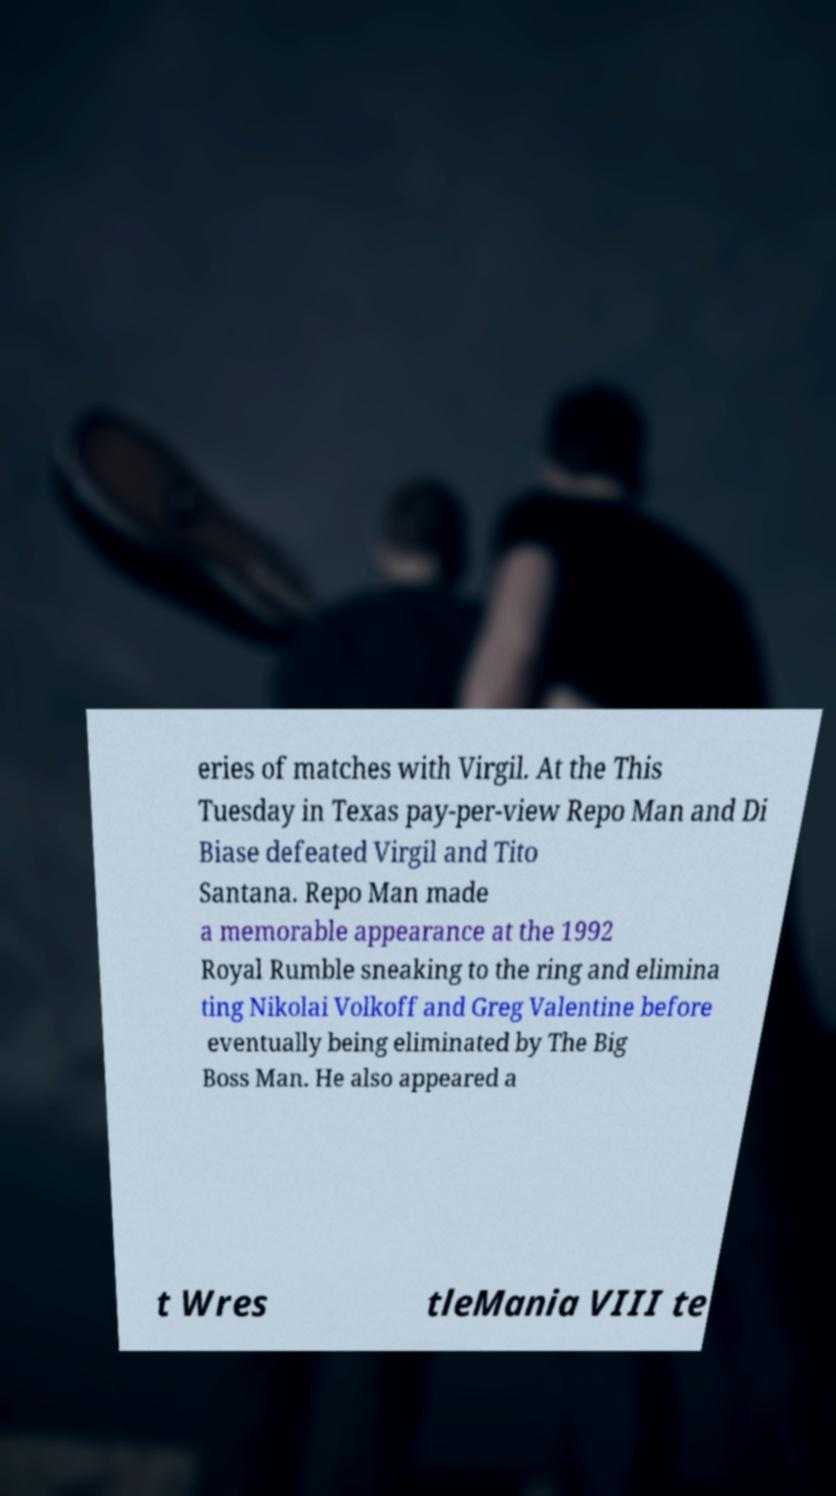Could you assist in decoding the text presented in this image and type it out clearly? eries of matches with Virgil. At the This Tuesday in Texas pay-per-view Repo Man and Di Biase defeated Virgil and Tito Santana. Repo Man made a memorable appearance at the 1992 Royal Rumble sneaking to the ring and elimina ting Nikolai Volkoff and Greg Valentine before eventually being eliminated by The Big Boss Man. He also appeared a t Wres tleMania VIII te 